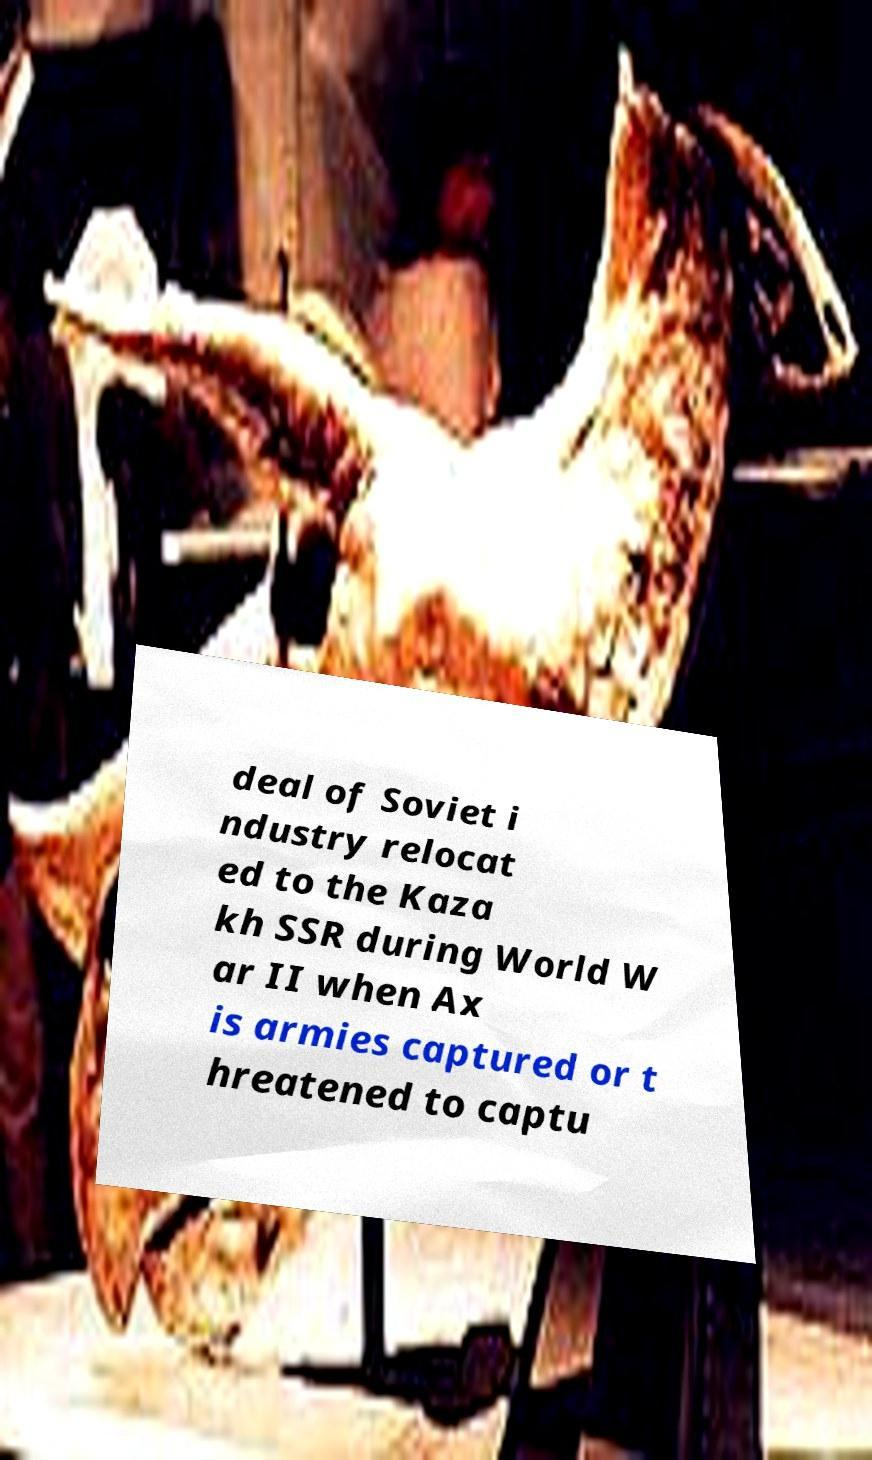What messages or text are displayed in this image? I need them in a readable, typed format. deal of Soviet i ndustry relocat ed to the Kaza kh SSR during World W ar II when Ax is armies captured or t hreatened to captu 